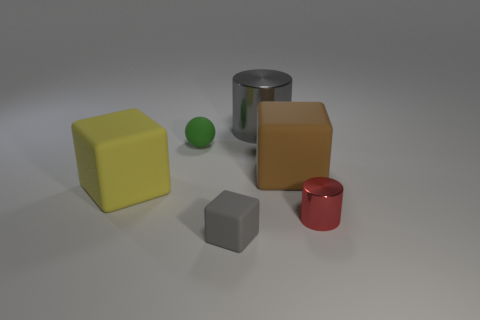Add 4 small gray matte blocks. How many objects exist? 10 Subtract all cylinders. How many objects are left? 4 Add 6 matte blocks. How many matte blocks are left? 9 Add 6 big rubber cubes. How many big rubber cubes exist? 8 Subtract 0 purple spheres. How many objects are left? 6 Subtract all big yellow matte things. Subtract all cylinders. How many objects are left? 3 